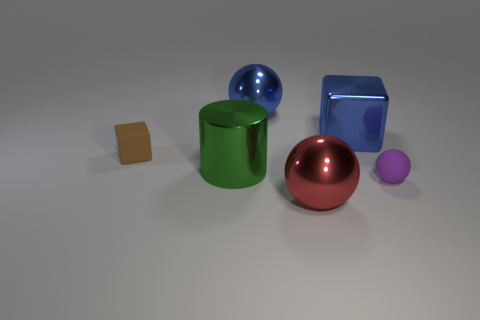Is the color of the large shiny cube the same as the rubber cube?
Keep it short and to the point. No. What color is the cube that is the same size as the cylinder?
Give a very brief answer. Blue. How many cyan things are either matte cubes or large metallic spheres?
Keep it short and to the point. 0. Is the number of blue metal objects greater than the number of tiny purple shiny spheres?
Offer a very short reply. Yes. There is a object in front of the purple thing; is its size the same as the rubber thing to the left of the purple matte object?
Your answer should be compact. No. The tiny rubber object in front of the small thing behind the cylinder left of the tiny rubber sphere is what color?
Your response must be concise. Purple. Are there any small purple matte things of the same shape as the brown rubber thing?
Make the answer very short. No. Is the number of small brown things in front of the small block greater than the number of large things?
Your answer should be compact. No. What number of metallic objects are either red things or blue things?
Your response must be concise. 3. What size is the thing that is both left of the blue ball and on the right side of the small brown thing?
Keep it short and to the point. Large. 